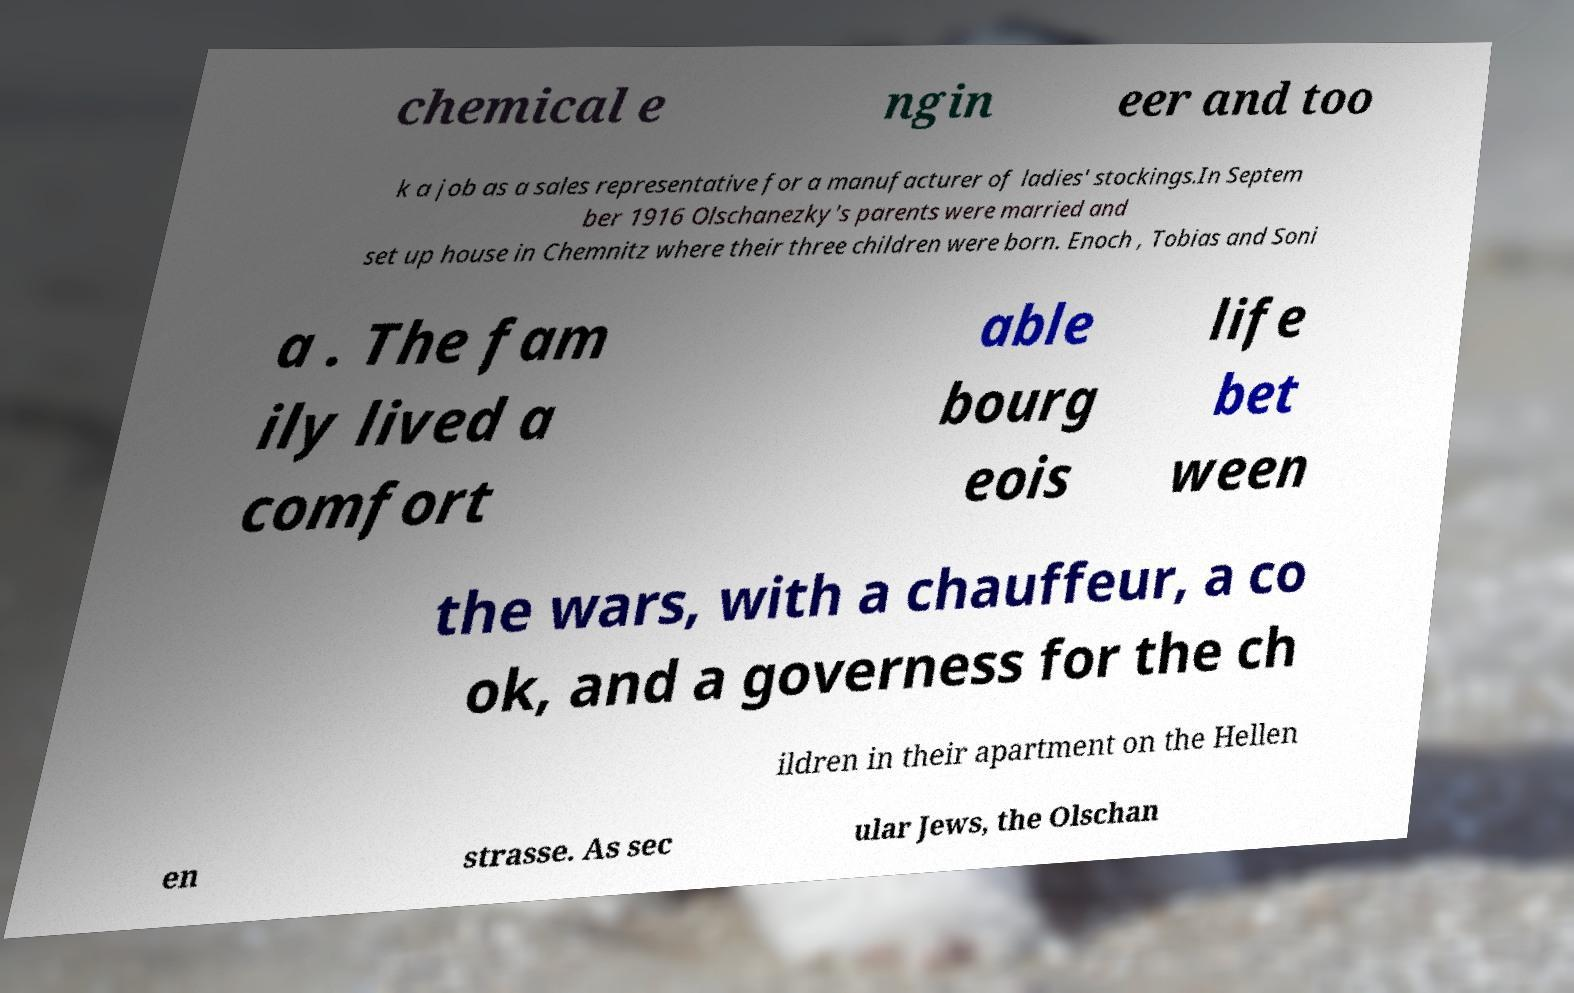Can you accurately transcribe the text from the provided image for me? chemical e ngin eer and too k a job as a sales representative for a manufacturer of ladies' stockings.In Septem ber 1916 Olschanezky's parents were married and set up house in Chemnitz where their three children were born. Enoch , Tobias and Soni a . The fam ily lived a comfort able bourg eois life bet ween the wars, with a chauffeur, a co ok, and a governess for the ch ildren in their apartment on the Hellen en strasse. As sec ular Jews, the Olschan 